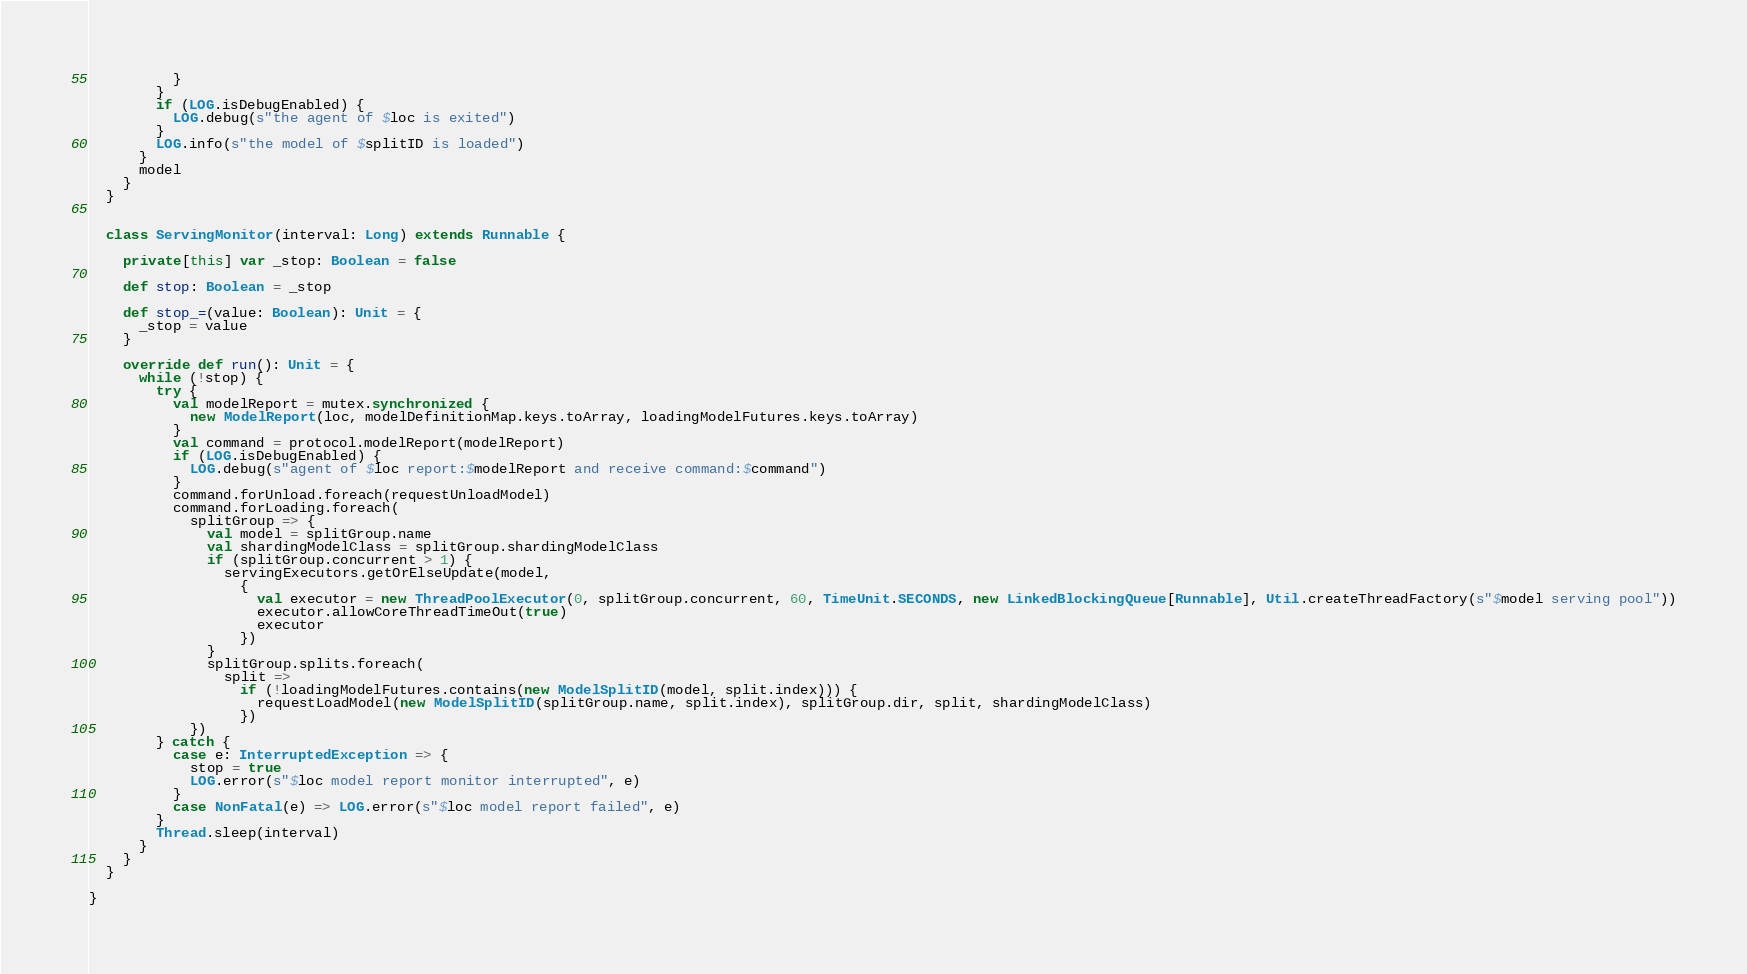<code> <loc_0><loc_0><loc_500><loc_500><_Scala_>          }
        }
        if (LOG.isDebugEnabled) {
          LOG.debug(s"the agent of $loc is exited")
        }
        LOG.info(s"the model of $splitID is loaded")
      }
      model
    }
  }


  class ServingMonitor(interval: Long) extends Runnable {

    private[this] var _stop: Boolean = false

    def stop: Boolean = _stop

    def stop_=(value: Boolean): Unit = {
      _stop = value
    }

    override def run(): Unit = {
      while (!stop) {
        try {
          val modelReport = mutex.synchronized {
            new ModelReport(loc, modelDefinitionMap.keys.toArray, loadingModelFutures.keys.toArray)
          }
          val command = protocol.modelReport(modelReport)
          if (LOG.isDebugEnabled) {
            LOG.debug(s"agent of $loc report:$modelReport and receive command:$command")
          }
          command.forUnload.foreach(requestUnloadModel)
          command.forLoading.foreach(
            splitGroup => {
              val model = splitGroup.name
              val shardingModelClass = splitGroup.shardingModelClass
              if (splitGroup.concurrent > 1) {
                servingExecutors.getOrElseUpdate(model,
                  {
                    val executor = new ThreadPoolExecutor(0, splitGroup.concurrent, 60, TimeUnit.SECONDS, new LinkedBlockingQueue[Runnable], Util.createThreadFactory(s"$model serving pool"))
                    executor.allowCoreThreadTimeOut(true)
                    executor
                  })
              }
              splitGroup.splits.foreach(
                split =>
                  if (!loadingModelFutures.contains(new ModelSplitID(model, split.index))) {
                    requestLoadModel(new ModelSplitID(splitGroup.name, split.index), splitGroup.dir, split, shardingModelClass)
                  })
            })
        } catch {
          case e: InterruptedException => {
            stop = true
            LOG.error(s"$loc model report monitor interrupted", e)
          }
          case NonFatal(e) => LOG.error(s"$loc model report failed", e)
        }
        Thread.sleep(interval)
      }
    }
  }

}
</code> 